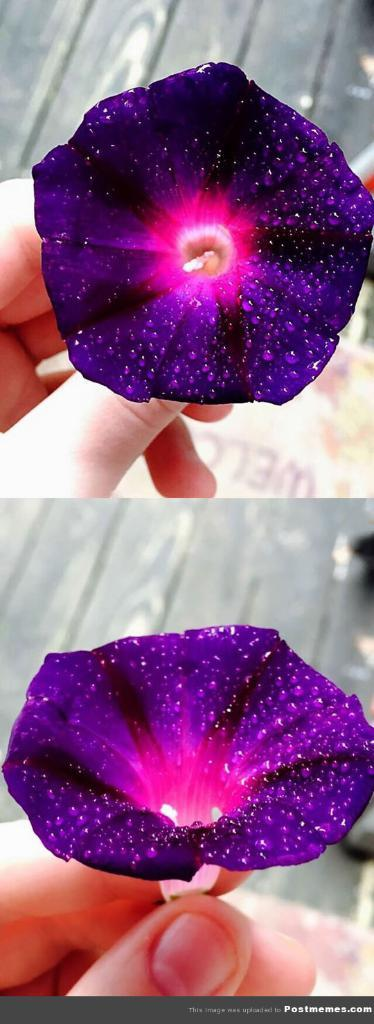What can be seen in the image? There is a human hand in the image. What is the hand holding? The hand is holding a flower. Can you describe the flower? The flower is purple and pink in color. What type of spark can be seen coming from the hand in the image? There is no spark present in the image; it only shows a hand holding a flower. 